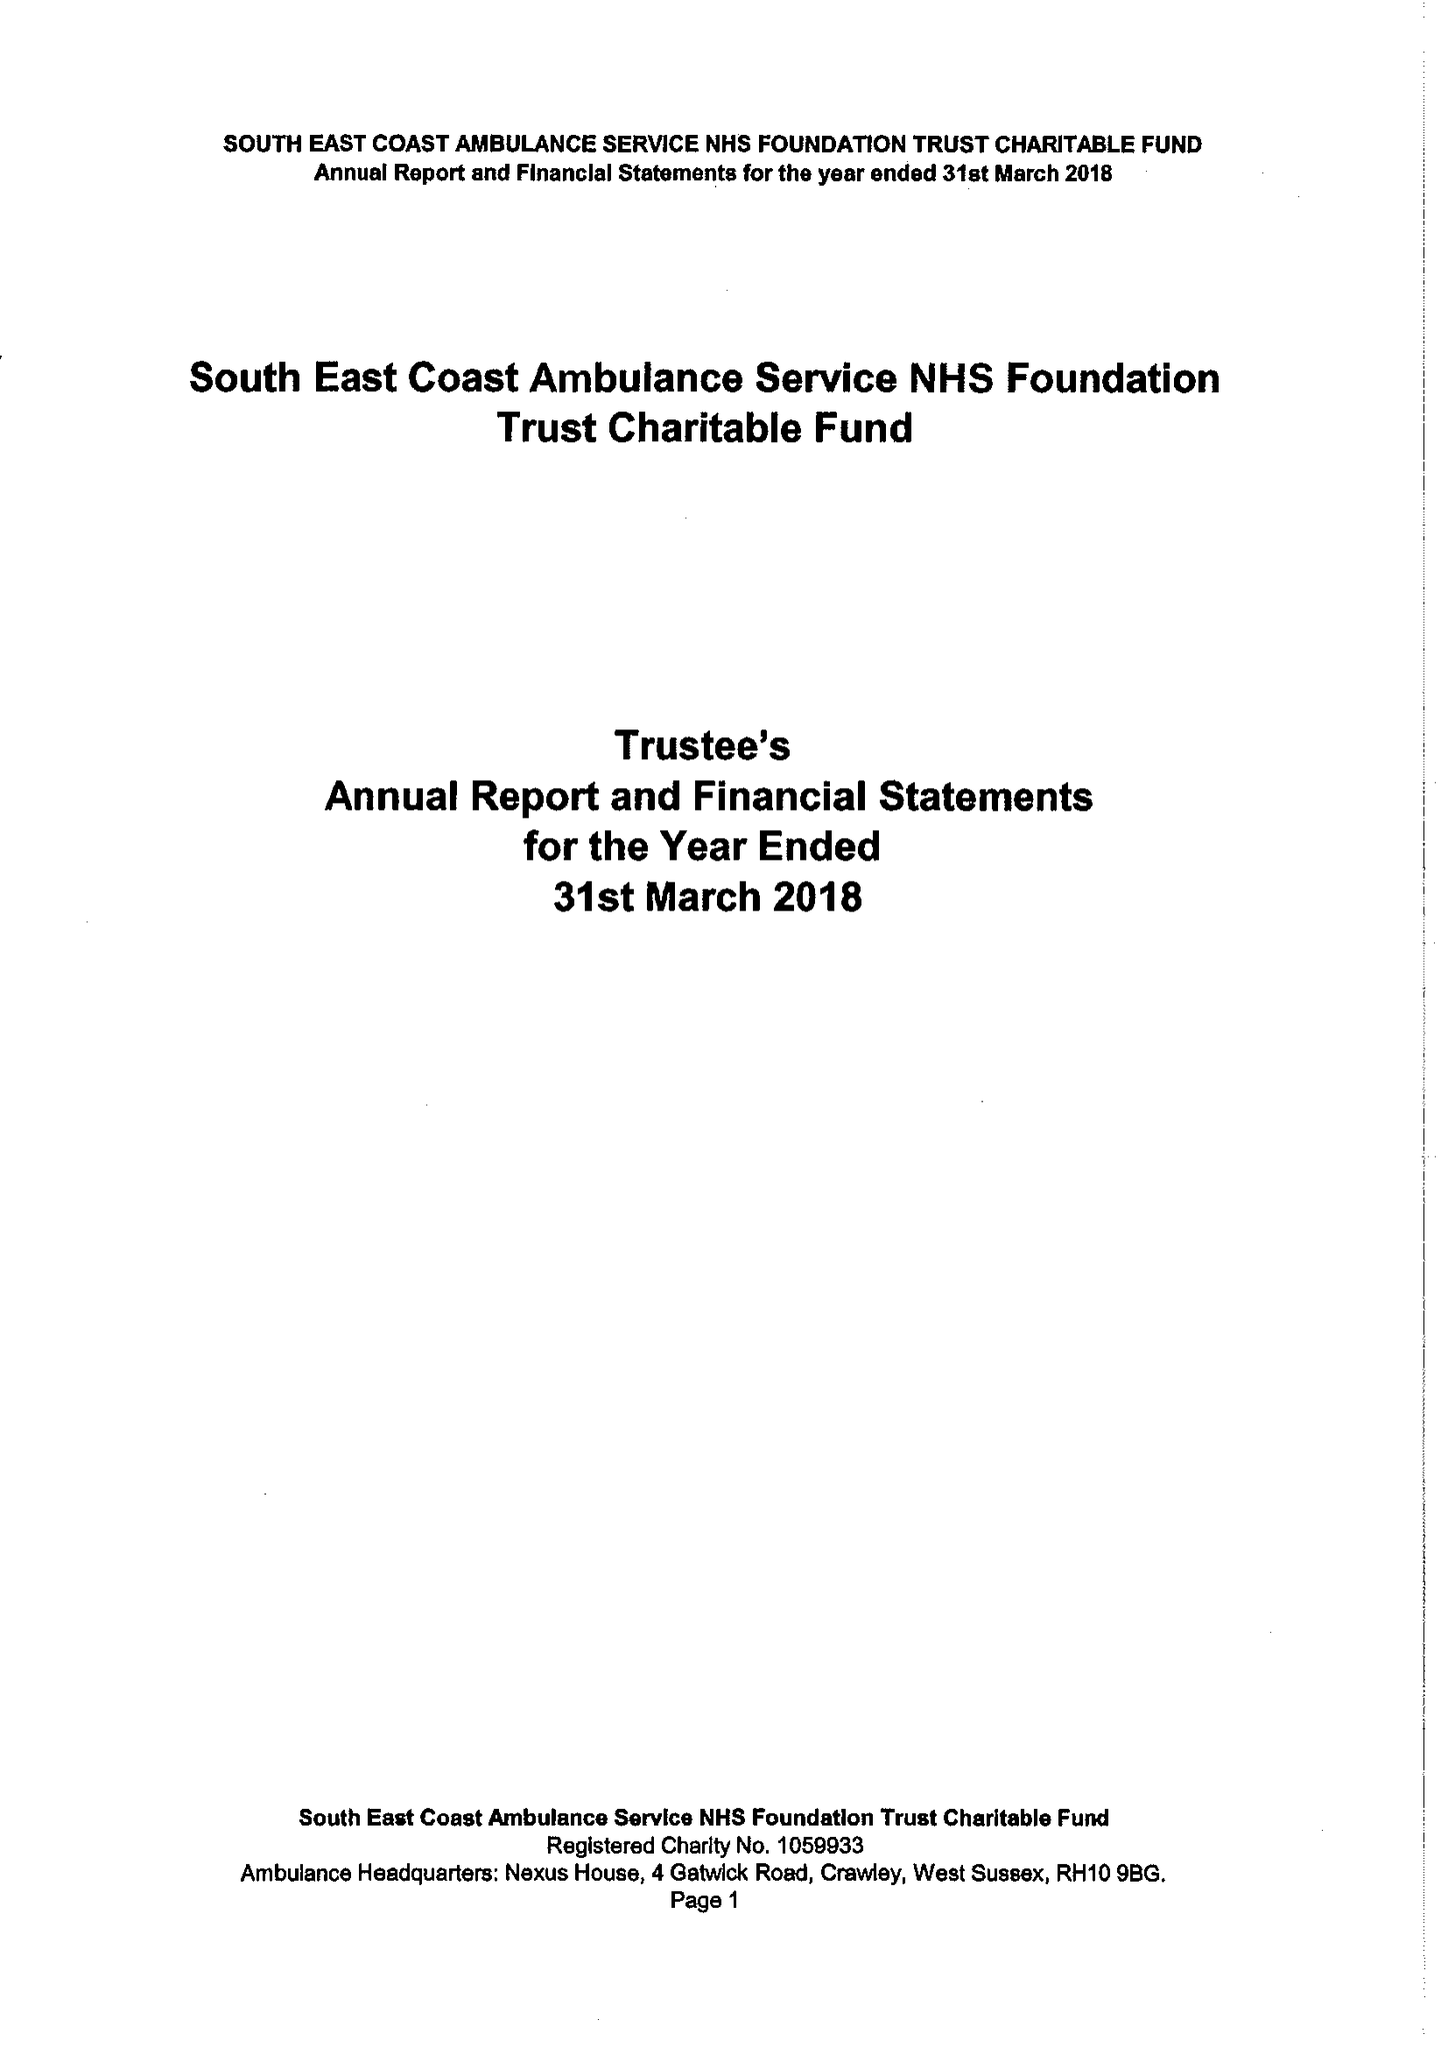What is the value for the address__post_town?
Answer the question using a single word or phrase. CRAWLEY 